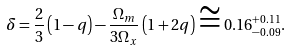<formula> <loc_0><loc_0><loc_500><loc_500>\delta = \frac { 2 } { 3 } \left ( { 1 - q } \right ) - \frac { \Omega _ { m } } { 3 \Omega _ { x } } \left ( { 1 + 2 q } \right ) \cong 0 . 1 6 _ { - 0 . 0 9 } ^ { + 0 . 1 1 } .</formula> 